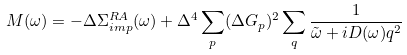Convert formula to latex. <formula><loc_0><loc_0><loc_500><loc_500>M ( \omega ) = - \Delta \Sigma _ { i m p } ^ { R A } ( \omega ) + \Delta ^ { 4 } \sum _ { p } ( \Delta G _ { p } ) ^ { 2 } \sum _ { q } \frac { 1 } { \tilde { \omega } + i D ( \omega ) q ^ { 2 } }</formula> 